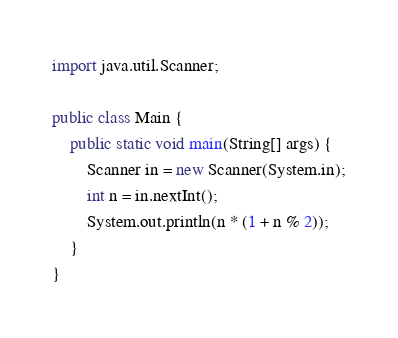Convert code to text. <code><loc_0><loc_0><loc_500><loc_500><_Java_>import java.util.Scanner;

public class Main {
    public static void main(String[] args) {
        Scanner in = new Scanner(System.in);
        int n = in.nextInt();
        System.out.println(n * (1 + n % 2));
    }
}</code> 